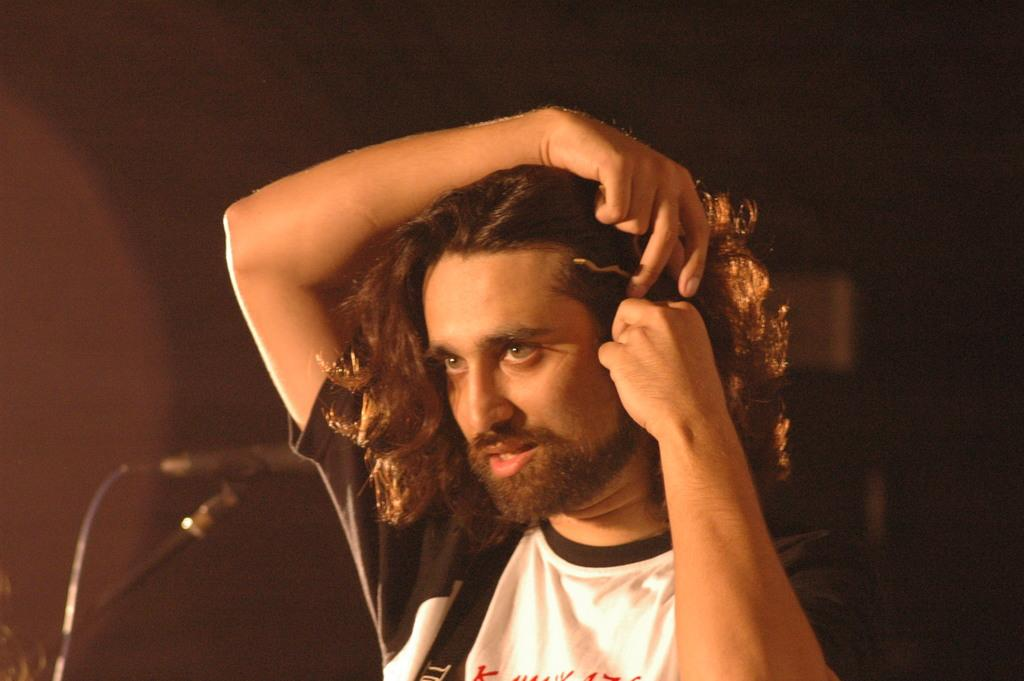Who is the main subject in the image? There is a man in the image. What is the man doing in the image? The man is adjusting his hair. What object is present in the image that is commonly used for amplifying sound? There is a microphone present in the image. What type of light bulb is being used by the band in the image? There is no band or light bulb present in the image; it only features a man adjusting his hair and a microphone. 